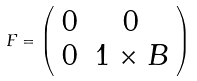Convert formula to latex. <formula><loc_0><loc_0><loc_500><loc_500>F = \left ( \begin{array} { c c } 0 & { 0 } \\ { 0 } & { 1 } \times { B } \end{array} \right )</formula> 